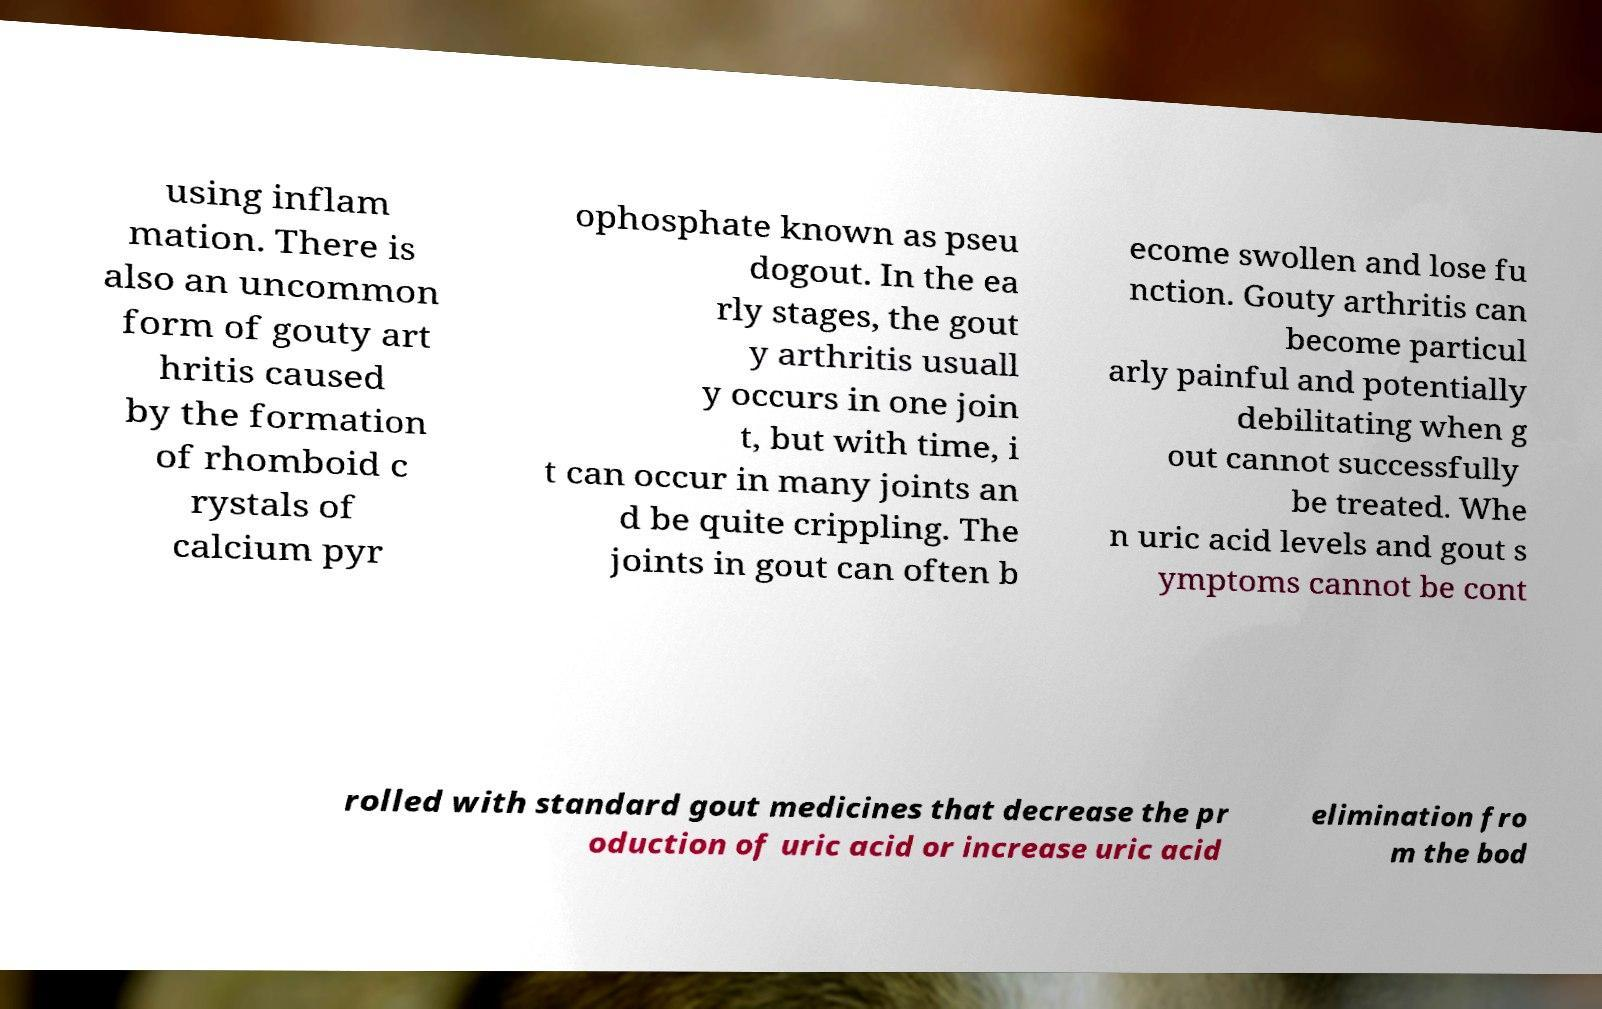Please identify and transcribe the text found in this image. using inflam mation. There is also an uncommon form of gouty art hritis caused by the formation of rhomboid c rystals of calcium pyr ophosphate known as pseu dogout. In the ea rly stages, the gout y arthritis usuall y occurs in one join t, but with time, i t can occur in many joints an d be quite crippling. The joints in gout can often b ecome swollen and lose fu nction. Gouty arthritis can become particul arly painful and potentially debilitating when g out cannot successfully be treated. Whe n uric acid levels and gout s ymptoms cannot be cont rolled with standard gout medicines that decrease the pr oduction of uric acid or increase uric acid elimination fro m the bod 